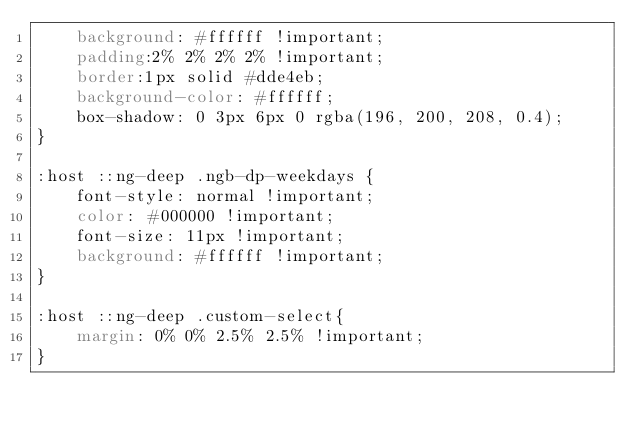Convert code to text. <code><loc_0><loc_0><loc_500><loc_500><_CSS_>    background: #ffffff !important;
    padding:2% 2% 2% 2% !important;
    border:1px solid #dde4eb;
    background-color: #ffffff;
    box-shadow: 0 3px 6px 0 rgba(196, 200, 208, 0.4);
}

:host ::ng-deep .ngb-dp-weekdays {
    font-style: normal !important;
    color: #000000 !important;
    font-size: 11px !important;
    background: #ffffff !important;
}

:host ::ng-deep .custom-select{
    margin: 0% 0% 2.5% 2.5% !important;
}</code> 